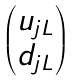Convert formula to latex. <formula><loc_0><loc_0><loc_500><loc_500>\begin{pmatrix} u _ { j L } \\ d _ { j L } \end{pmatrix}</formula> 